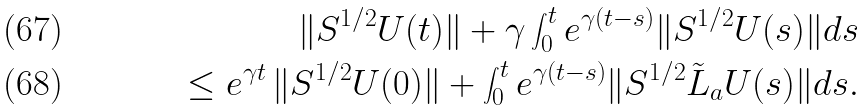<formula> <loc_0><loc_0><loc_500><loc_500>\| S ^ { 1 / 2 } U ( t ) \| + \gamma \int _ { 0 } ^ { t } e ^ { \gamma ( t - s ) } \| S ^ { 1 / 2 } U ( s ) \| d s \\ \leq e ^ { \gamma t } \, \| S ^ { 1 / 2 } U ( 0 ) \| + \int _ { 0 } ^ { t } e ^ { \gamma ( t - s ) } \| S ^ { 1 / 2 } { \tilde { L } } _ { a } U ( s ) \| d s .</formula> 